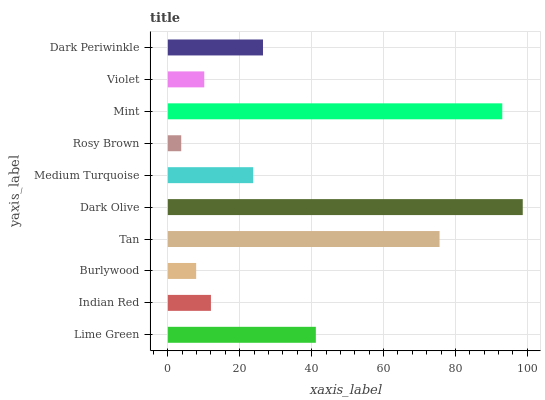Is Rosy Brown the minimum?
Answer yes or no. Yes. Is Dark Olive the maximum?
Answer yes or no. Yes. Is Indian Red the minimum?
Answer yes or no. No. Is Indian Red the maximum?
Answer yes or no. No. Is Lime Green greater than Indian Red?
Answer yes or no. Yes. Is Indian Red less than Lime Green?
Answer yes or no. Yes. Is Indian Red greater than Lime Green?
Answer yes or no. No. Is Lime Green less than Indian Red?
Answer yes or no. No. Is Dark Periwinkle the high median?
Answer yes or no. Yes. Is Medium Turquoise the low median?
Answer yes or no. Yes. Is Violet the high median?
Answer yes or no. No. Is Mint the low median?
Answer yes or no. No. 